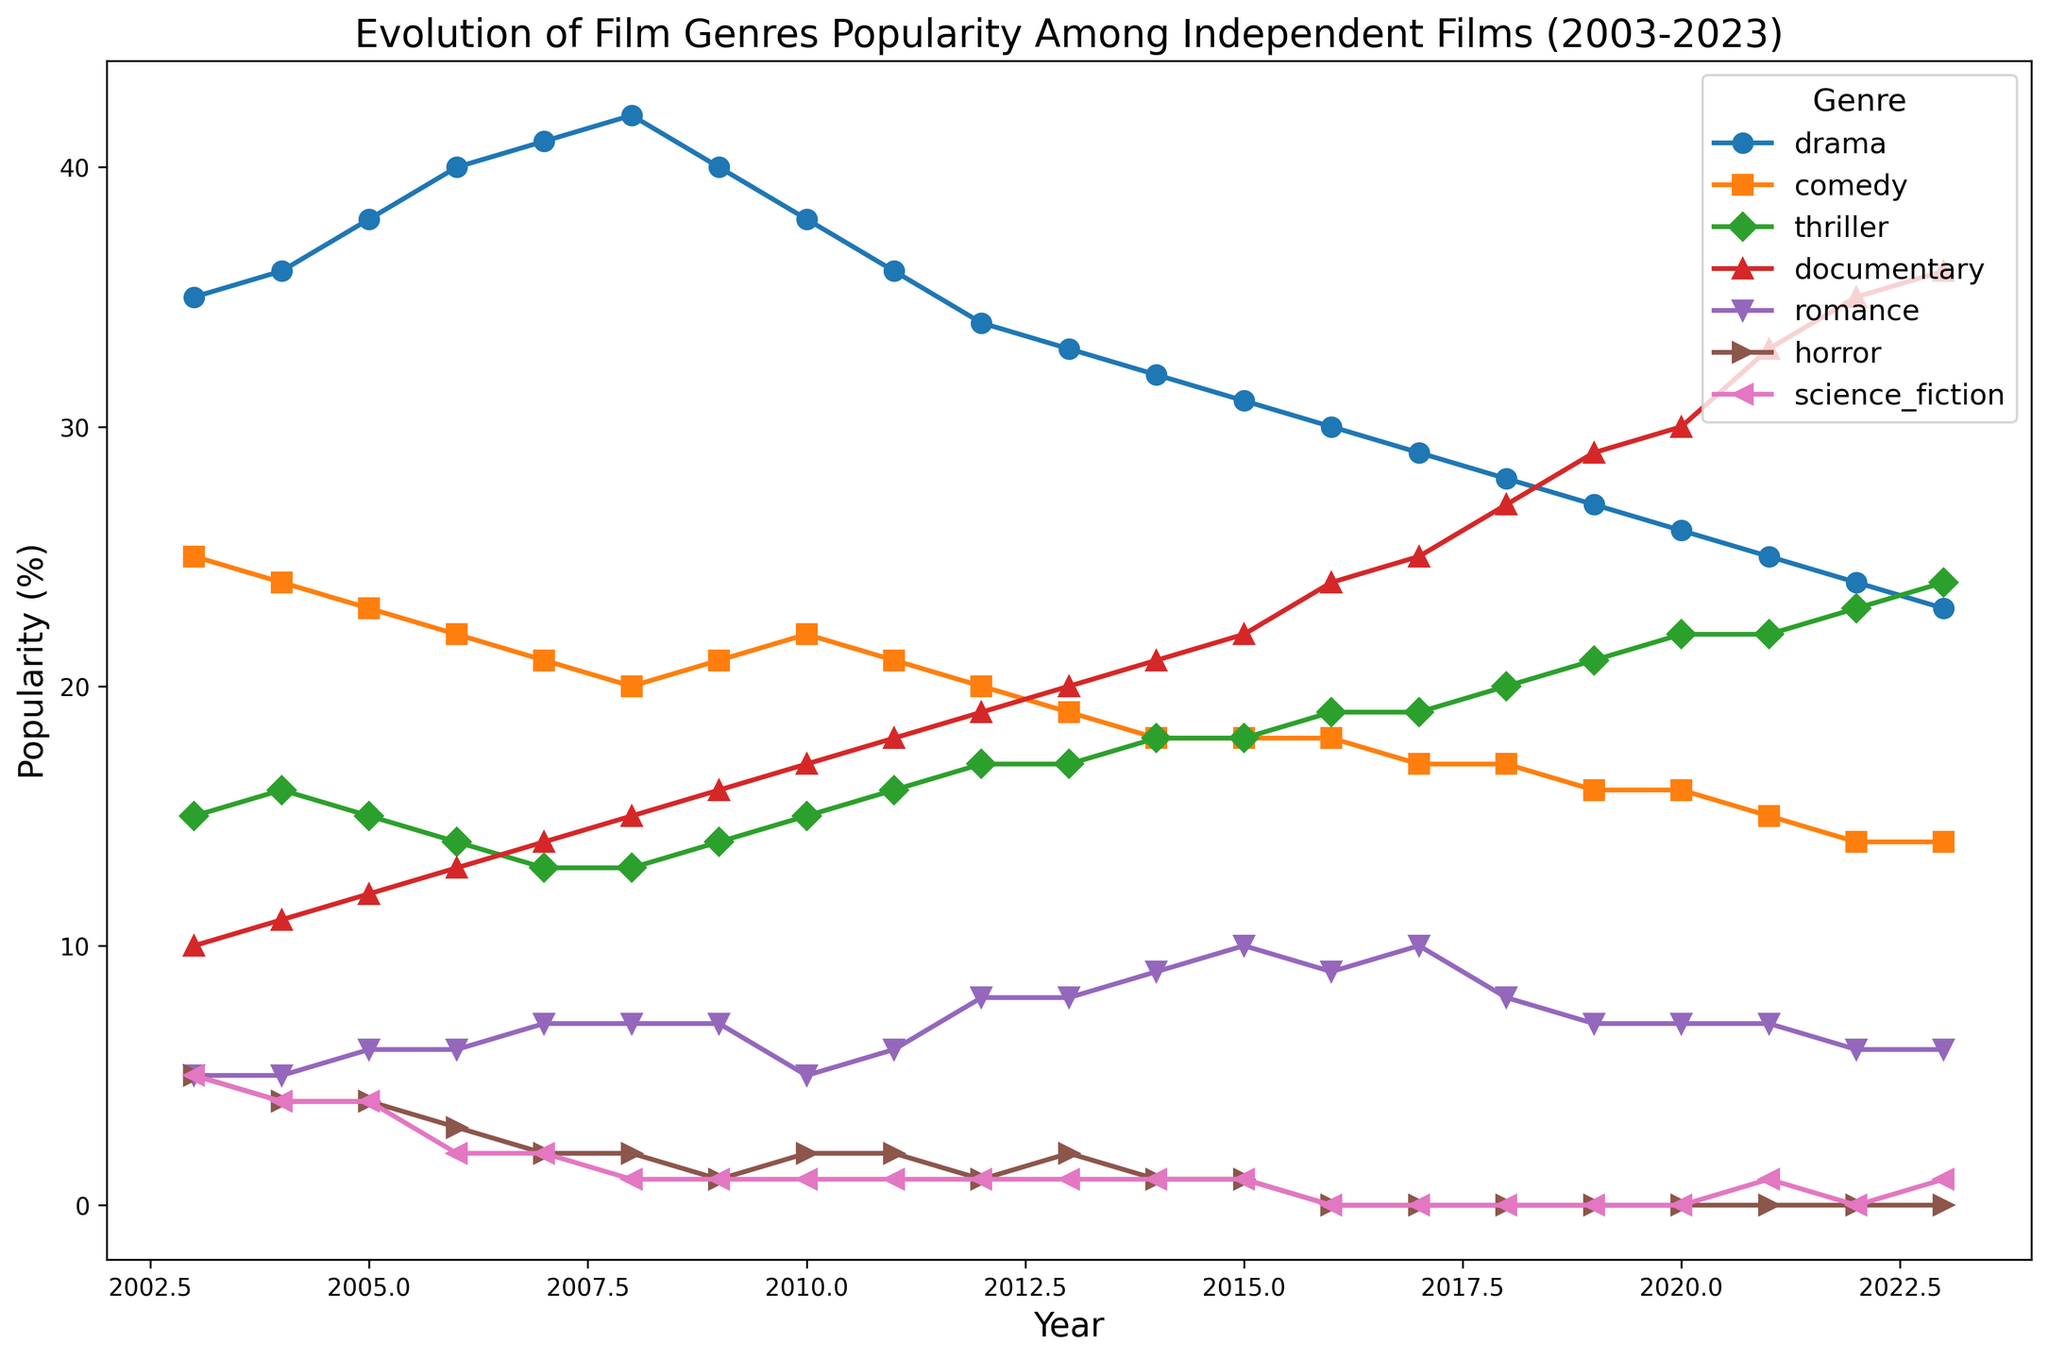What year did documentaries surpass dramas in popularity? Documentaries started at 10% popularity in 2003 and steadily increased, while dramas started at 35% in 2003 and gradually decreased. Looking at the intersection, documentaries surpassed dramas in 2021.
Answer: 2021 Which genre experienced the sharpest decline in popularity over the 20-year span? By observing the gradient of the lines, horror shows a significant drop from 5% in 2003 to 0% by 2016, indicating the sharpest decline among all genres.
Answer: Horror Which genre has remained relatively stable in popularity over the years? Comedy started at 25% in 2003 and ended at 14% in 2023. Its line is comparatively flatter suggesting stability, unlike genres with steep inclines or declines.
Answer: Comedy In which year did documentaries and thrillers both have 19% popularity? Tracking the values of documentaries and thrillers, 2016 shows documentaries at 24% and thrillers at 19%. By checking subsequent years, we find documentaries at 19% and thrillers at 17% in 2012.
Answer: 2012 Which genre showed a consistent upward trend throughout the period? By inspecting the slopes, documentaries increased steadily from 10% in 2003 to 36% in 2023, showing a consistent upward trend.
Answer: Documentary Identify the year when romance films reached 10% popularity for the first time. Tracking the data points for romance, it reached 10% popularity first in 2015.
Answer: 2015 How many genres had a decreasing trend over the last 10 years? (2014-2023) Drama, comedy, romance, and thrillers were prominent. Drama decreased from 32% (2014) to 23% (2023), comedy from 18% to 14%, romance from 9% to 6%, thrillers from 18% to 24%, and horror remained negligible. Counting the declining trends: drama, comedy = 2 genres.
Answer: 2 genres Which genre was more popular in 2009 compared to 2018? In 2009: Drama 40%, Comedy 21%, Thriller 14%, Documentary 16%, Romance 7%, Horror 1%, Sci-Fi 1%. In 2018: Drama 28%, Comedy 17%, Thriller 20%, Documentary 27%, Romance 8%, Horror 0%, Sci-Fi 0%. The only genre showing higher popularity in 2009 compared to 2018 was Drama.
Answer: Drama What is the average popularity of horror films between 2003 to 2023? Adding the values of horror: 5, 4, 4, 3, 2, 2, 1, 2, 2, 1, 1, 1, 1, 0, 0, 0, 0, 0, 0, 0. Summing these values = 29. Average over 20 years is 29/20.
Answer: 1.45 How does the popularity of science fiction in the last three equal to its popularity in the first ten years of the span? Sci-fi in last 3 years (2021-2023): 0, 1, 0; Total: 1. In first 10 years (2003-2012): 5, 4, 4, 2, 2, 1, 1, 1, 1, 1; Total: 22. Hence, popularity in first 10 years is significantly more than the last three years.
Answer: First ten years high than last three 